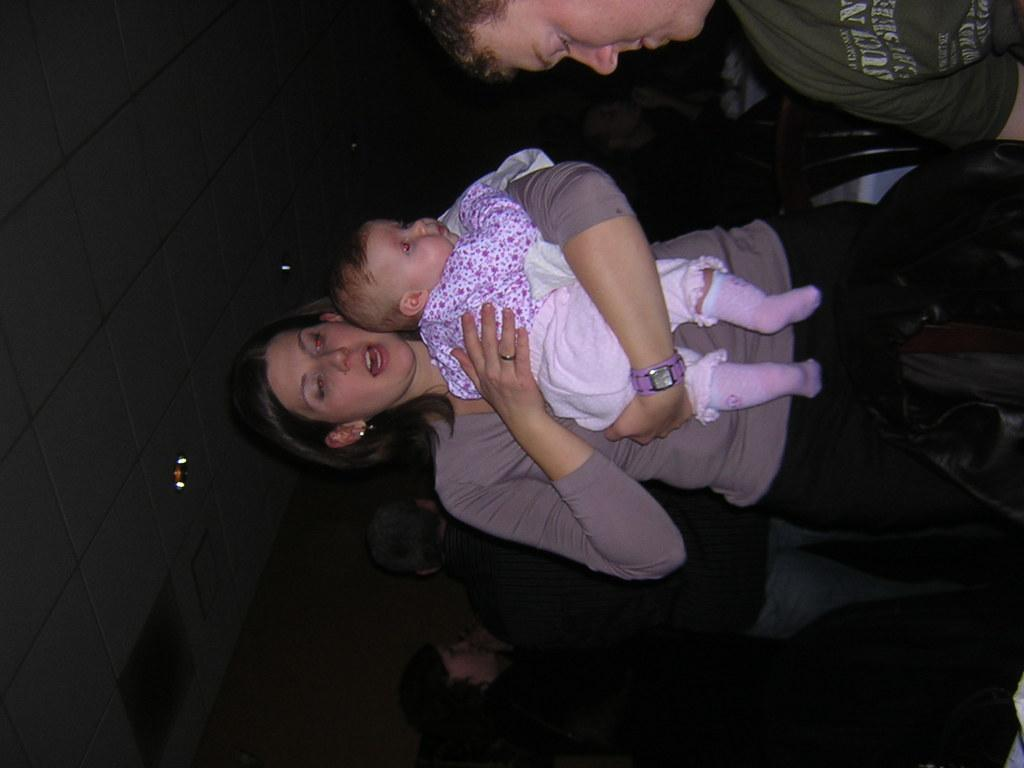How many people are in the image? There is a group of people in the image. What can be observed about the clothing of the people in the image? The people are wearing different color dresses. What is visible to the left side of the image? There are lights and a wall visible to the left of the image. What type of sweater is the airplane wearing in the image? There is no airplane or sweater present in the image. 